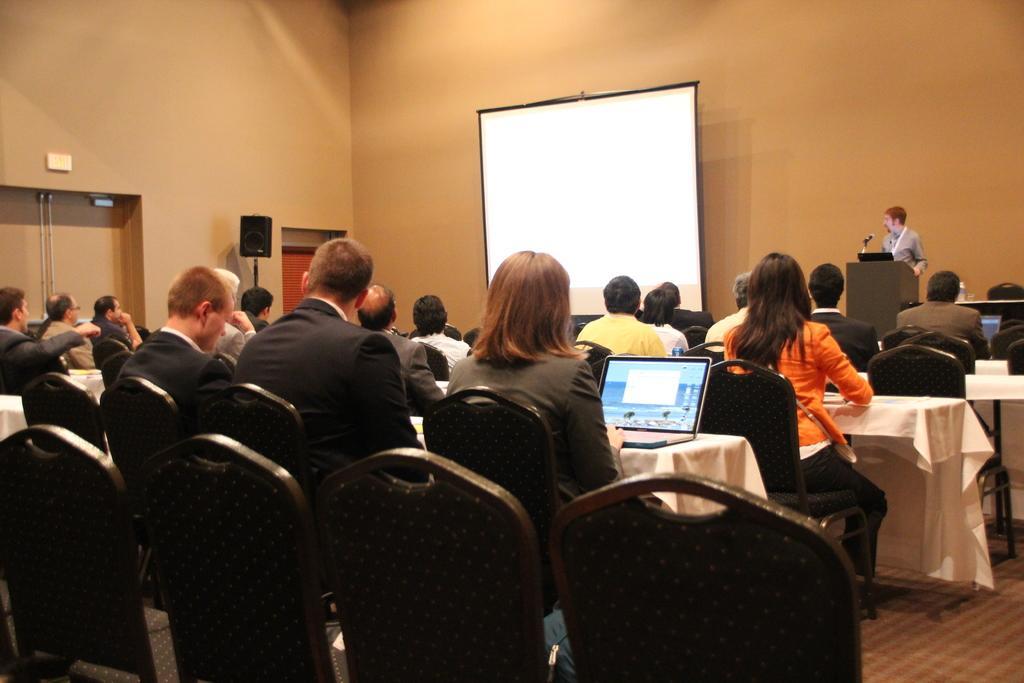How would you summarize this image in a sentence or two? In the picture we can see a people sitting on the chairs near the table and we can also see some laptops, on the stage we can see one man is standing on a stage and explaining something to the people. And we can also see the screen, wall, door and sound set. 